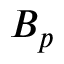Convert formula to latex. <formula><loc_0><loc_0><loc_500><loc_500>B _ { p }</formula> 